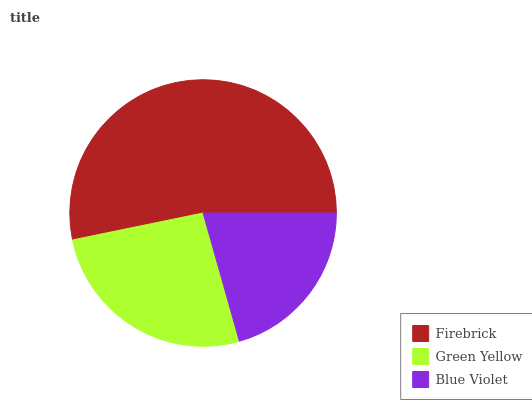Is Blue Violet the minimum?
Answer yes or no. Yes. Is Firebrick the maximum?
Answer yes or no. Yes. Is Green Yellow the minimum?
Answer yes or no. No. Is Green Yellow the maximum?
Answer yes or no. No. Is Firebrick greater than Green Yellow?
Answer yes or no. Yes. Is Green Yellow less than Firebrick?
Answer yes or no. Yes. Is Green Yellow greater than Firebrick?
Answer yes or no. No. Is Firebrick less than Green Yellow?
Answer yes or no. No. Is Green Yellow the high median?
Answer yes or no. Yes. Is Green Yellow the low median?
Answer yes or no. Yes. Is Firebrick the high median?
Answer yes or no. No. Is Firebrick the low median?
Answer yes or no. No. 